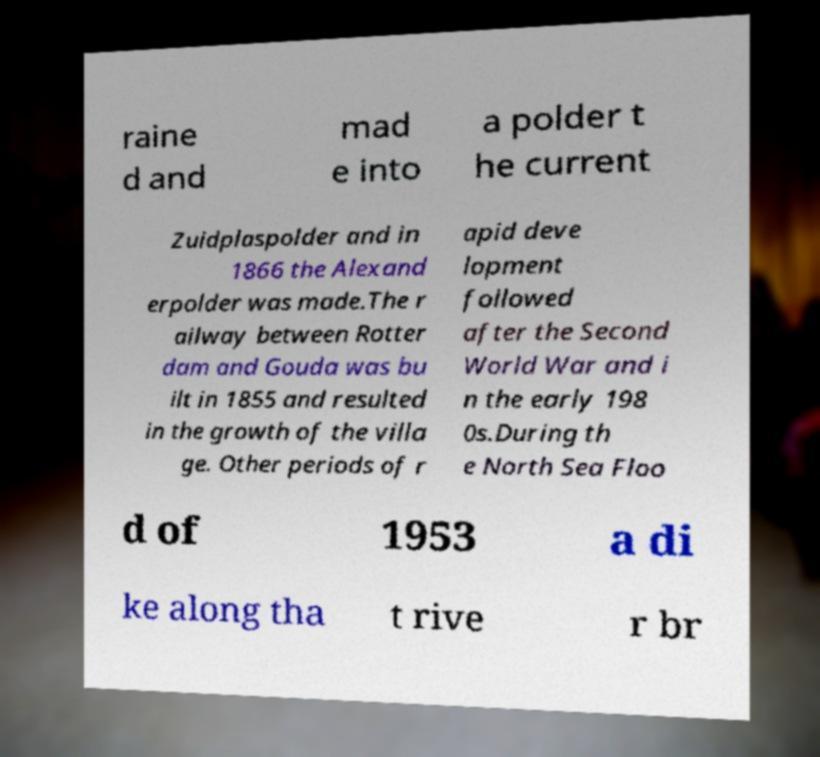Can you read and provide the text displayed in the image?This photo seems to have some interesting text. Can you extract and type it out for me? raine d and mad e into a polder t he current Zuidplaspolder and in 1866 the Alexand erpolder was made.The r ailway between Rotter dam and Gouda was bu ilt in 1855 and resulted in the growth of the villa ge. Other periods of r apid deve lopment followed after the Second World War and i n the early 198 0s.During th e North Sea Floo d of 1953 a di ke along tha t rive r br 